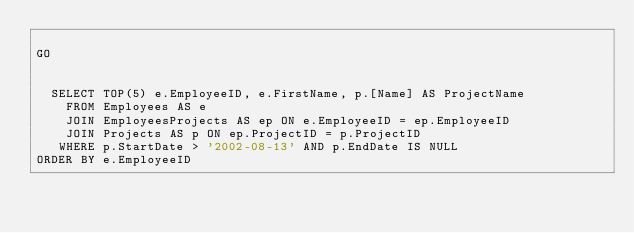Convert code to text. <code><loc_0><loc_0><loc_500><loc_500><_SQL_>
GO


  SELECT TOP(5) e.EmployeeID, e.FirstName, p.[Name] AS ProjectName
    FROM Employees AS e
    JOIN EmployeesProjects AS ep ON e.EmployeeID = ep.EmployeeID
    JOIN Projects AS p ON ep.ProjectID = p.ProjectID
   WHERE p.StartDate > '2002-08-13' AND p.EndDate IS NULL
ORDER BY e.EmployeeID</code> 